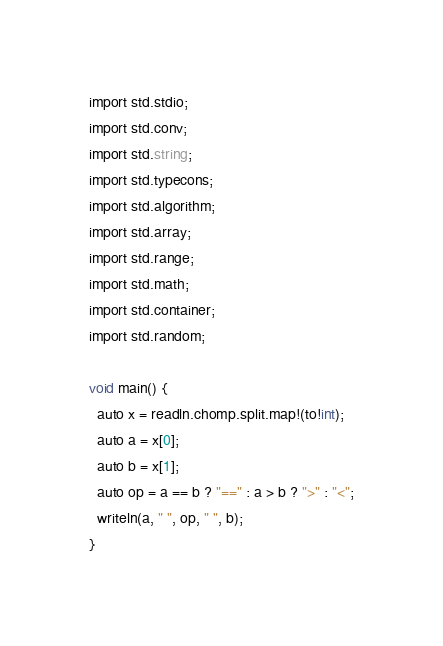<code> <loc_0><loc_0><loc_500><loc_500><_D_>import std.stdio;
import std.conv;
import std.string;
import std.typecons;
import std.algorithm;
import std.array;
import std.range;
import std.math;
import std.container;
import std.random;
 
void main() {
  auto x = readln.chomp.split.map!(to!int);
  auto a = x[0];
  auto b = x[1];
  auto op = a == b ? "==" : a > b ? ">" : "<";
  writeln(a, " ", op, " ", b);
}</code> 